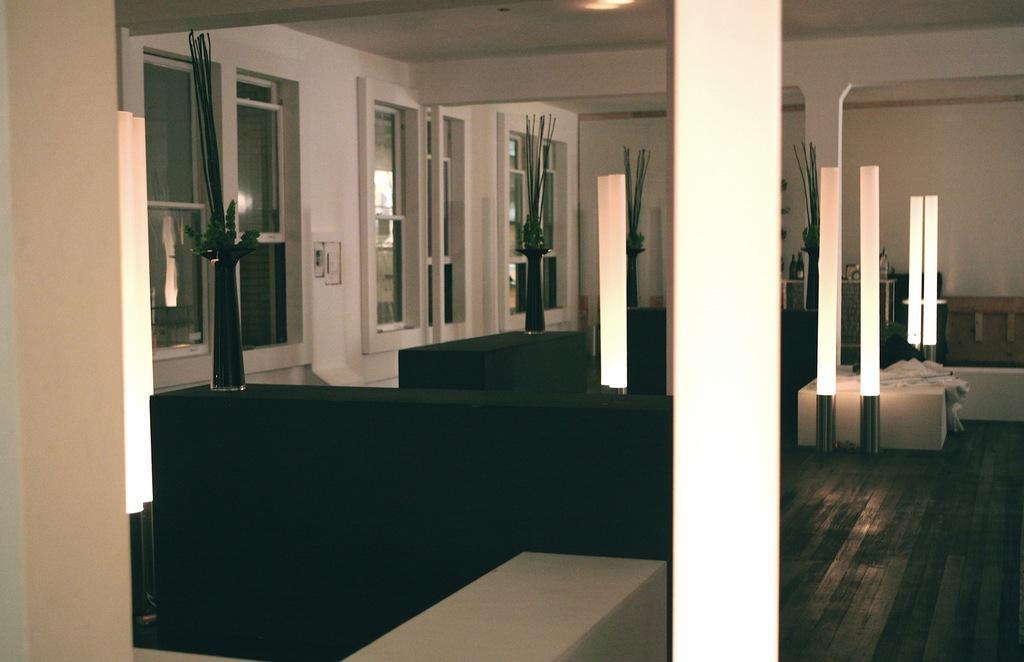Please provide a concise description of this image. This picture is clicked inside. In the foreground we can see the flower vases placed on the top of the green color tables. On the right we can see the lights and many number of objects placed on the ground. In the background there is a wall, pillars and windows. At the top there is roof and the ceiling lights. 